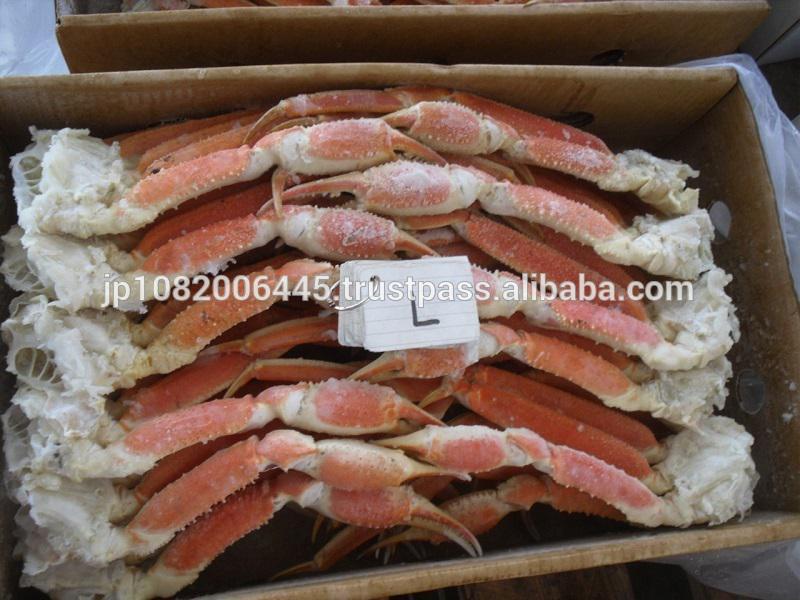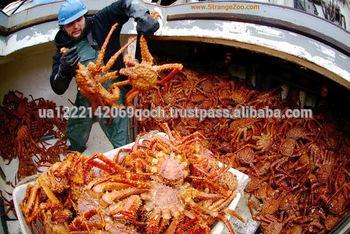The first image is the image on the left, the second image is the image on the right. Considering the images on both sides, is "There are two crabs" valid? Answer yes or no. No. 